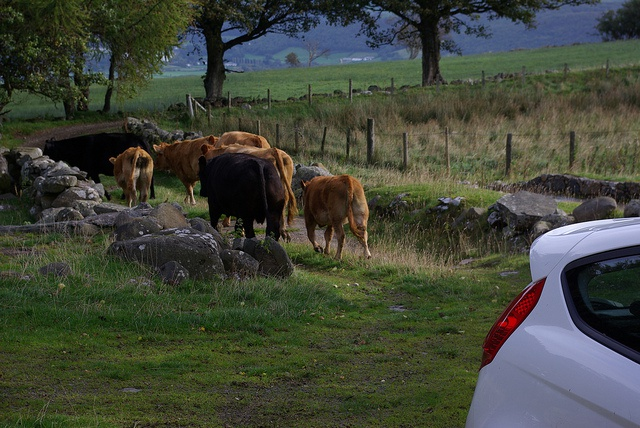Describe the objects in this image and their specific colors. I can see car in black, gray, and darkgray tones, cow in black and gray tones, cow in black, maroon, and gray tones, cow in black, gray, and maroon tones, and cow in black, maroon, and gray tones in this image. 